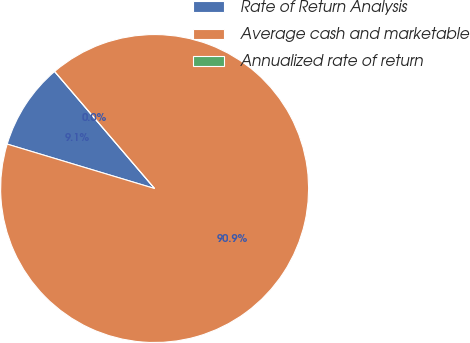Convert chart to OTSL. <chart><loc_0><loc_0><loc_500><loc_500><pie_chart><fcel>Rate of Return Analysis<fcel>Average cash and marketable<fcel>Annualized rate of return<nl><fcel>9.09%<fcel>90.91%<fcel>0.0%<nl></chart> 